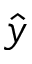<formula> <loc_0><loc_0><loc_500><loc_500>\hat { y }</formula> 